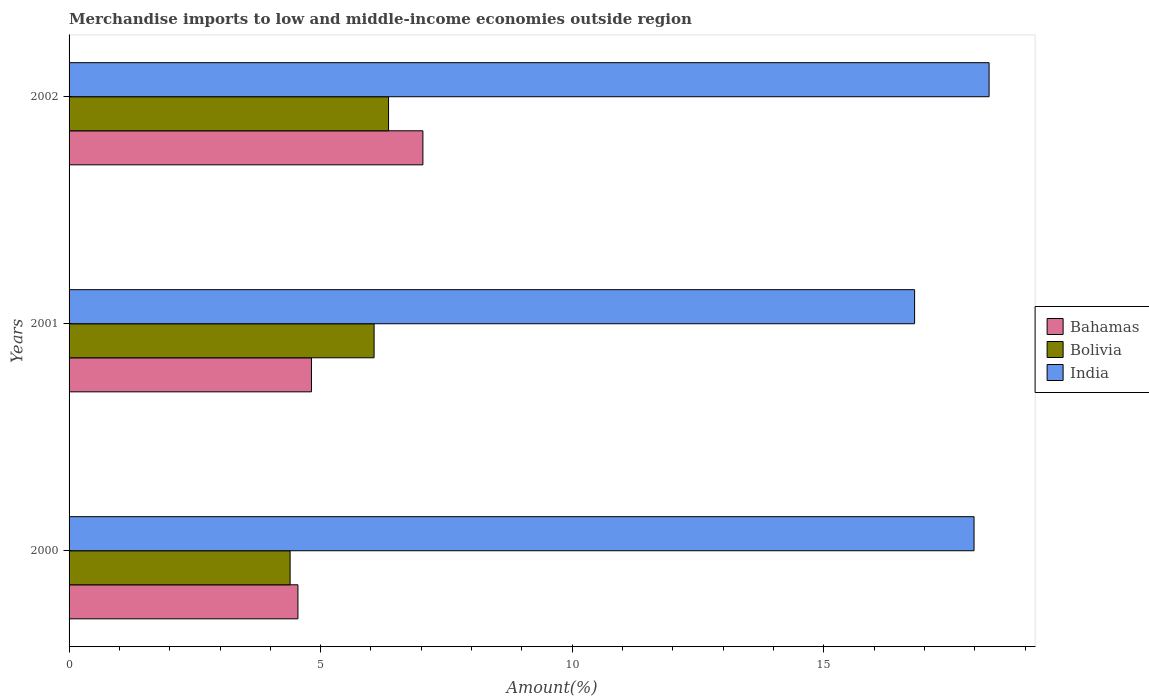How many different coloured bars are there?
Provide a short and direct response. 3. Are the number of bars per tick equal to the number of legend labels?
Offer a very short reply. Yes. What is the label of the 2nd group of bars from the top?
Offer a very short reply. 2001. What is the percentage of amount earned from merchandise imports in Bahamas in 2002?
Keep it short and to the point. 7.03. Across all years, what is the maximum percentage of amount earned from merchandise imports in India?
Your answer should be very brief. 18.28. Across all years, what is the minimum percentage of amount earned from merchandise imports in Bahamas?
Your answer should be very brief. 4.55. In which year was the percentage of amount earned from merchandise imports in Bahamas maximum?
Your answer should be very brief. 2002. What is the total percentage of amount earned from merchandise imports in Bahamas in the graph?
Ensure brevity in your answer.  16.4. What is the difference between the percentage of amount earned from merchandise imports in Bolivia in 2001 and that in 2002?
Your answer should be very brief. -0.29. What is the difference between the percentage of amount earned from merchandise imports in India in 2001 and the percentage of amount earned from merchandise imports in Bolivia in 2002?
Offer a terse response. 10.45. What is the average percentage of amount earned from merchandise imports in Bolivia per year?
Keep it short and to the point. 5.6. In the year 2000, what is the difference between the percentage of amount earned from merchandise imports in Bolivia and percentage of amount earned from merchandise imports in India?
Provide a short and direct response. -13.59. What is the ratio of the percentage of amount earned from merchandise imports in India in 2000 to that in 2001?
Keep it short and to the point. 1.07. What is the difference between the highest and the second highest percentage of amount earned from merchandise imports in Bolivia?
Provide a short and direct response. 0.29. What is the difference between the highest and the lowest percentage of amount earned from merchandise imports in Bolivia?
Your answer should be compact. 1.96. What does the 3rd bar from the top in 2002 represents?
Give a very brief answer. Bahamas. How many bars are there?
Provide a short and direct response. 9. Are all the bars in the graph horizontal?
Provide a short and direct response. Yes. What is the difference between two consecutive major ticks on the X-axis?
Make the answer very short. 5. Are the values on the major ticks of X-axis written in scientific E-notation?
Ensure brevity in your answer.  No. What is the title of the graph?
Provide a succinct answer. Merchandise imports to low and middle-income economies outside region. What is the label or title of the X-axis?
Provide a succinct answer. Amount(%). What is the label or title of the Y-axis?
Keep it short and to the point. Years. What is the Amount(%) of Bahamas in 2000?
Make the answer very short. 4.55. What is the Amount(%) in Bolivia in 2000?
Ensure brevity in your answer.  4.39. What is the Amount(%) of India in 2000?
Your response must be concise. 17.99. What is the Amount(%) of Bahamas in 2001?
Offer a very short reply. 4.82. What is the Amount(%) in Bolivia in 2001?
Your answer should be compact. 6.06. What is the Amount(%) of India in 2001?
Give a very brief answer. 16.8. What is the Amount(%) in Bahamas in 2002?
Give a very brief answer. 7.03. What is the Amount(%) in Bolivia in 2002?
Make the answer very short. 6.35. What is the Amount(%) of India in 2002?
Provide a short and direct response. 18.28. Across all years, what is the maximum Amount(%) of Bahamas?
Your answer should be very brief. 7.03. Across all years, what is the maximum Amount(%) of Bolivia?
Offer a very short reply. 6.35. Across all years, what is the maximum Amount(%) in India?
Make the answer very short. 18.28. Across all years, what is the minimum Amount(%) in Bahamas?
Your response must be concise. 4.55. Across all years, what is the minimum Amount(%) of Bolivia?
Make the answer very short. 4.39. Across all years, what is the minimum Amount(%) of India?
Provide a succinct answer. 16.8. What is the total Amount(%) of Bahamas in the graph?
Provide a short and direct response. 16.4. What is the total Amount(%) of Bolivia in the graph?
Your response must be concise. 16.8. What is the total Amount(%) of India in the graph?
Your response must be concise. 53.07. What is the difference between the Amount(%) of Bahamas in 2000 and that in 2001?
Provide a succinct answer. -0.27. What is the difference between the Amount(%) of Bolivia in 2000 and that in 2001?
Give a very brief answer. -1.67. What is the difference between the Amount(%) in India in 2000 and that in 2001?
Your response must be concise. 1.18. What is the difference between the Amount(%) in Bahamas in 2000 and that in 2002?
Ensure brevity in your answer.  -2.48. What is the difference between the Amount(%) of Bolivia in 2000 and that in 2002?
Give a very brief answer. -1.96. What is the difference between the Amount(%) of India in 2000 and that in 2002?
Provide a succinct answer. -0.3. What is the difference between the Amount(%) in Bahamas in 2001 and that in 2002?
Your answer should be compact. -2.22. What is the difference between the Amount(%) in Bolivia in 2001 and that in 2002?
Your answer should be very brief. -0.29. What is the difference between the Amount(%) in India in 2001 and that in 2002?
Your response must be concise. -1.48. What is the difference between the Amount(%) of Bahamas in 2000 and the Amount(%) of Bolivia in 2001?
Offer a very short reply. -1.51. What is the difference between the Amount(%) in Bahamas in 2000 and the Amount(%) in India in 2001?
Your answer should be compact. -12.26. What is the difference between the Amount(%) in Bolivia in 2000 and the Amount(%) in India in 2001?
Provide a succinct answer. -12.41. What is the difference between the Amount(%) in Bahamas in 2000 and the Amount(%) in Bolivia in 2002?
Your response must be concise. -1.8. What is the difference between the Amount(%) in Bahamas in 2000 and the Amount(%) in India in 2002?
Ensure brevity in your answer.  -13.74. What is the difference between the Amount(%) of Bolivia in 2000 and the Amount(%) of India in 2002?
Your answer should be compact. -13.89. What is the difference between the Amount(%) in Bahamas in 2001 and the Amount(%) in Bolivia in 2002?
Your answer should be compact. -1.53. What is the difference between the Amount(%) of Bahamas in 2001 and the Amount(%) of India in 2002?
Make the answer very short. -13.47. What is the difference between the Amount(%) in Bolivia in 2001 and the Amount(%) in India in 2002?
Offer a terse response. -12.22. What is the average Amount(%) of Bahamas per year?
Provide a short and direct response. 5.47. What is the average Amount(%) of Bolivia per year?
Make the answer very short. 5.6. What is the average Amount(%) of India per year?
Ensure brevity in your answer.  17.69. In the year 2000, what is the difference between the Amount(%) of Bahamas and Amount(%) of Bolivia?
Offer a very short reply. 0.16. In the year 2000, what is the difference between the Amount(%) in Bahamas and Amount(%) in India?
Provide a short and direct response. -13.44. In the year 2000, what is the difference between the Amount(%) in Bolivia and Amount(%) in India?
Your response must be concise. -13.59. In the year 2001, what is the difference between the Amount(%) of Bahamas and Amount(%) of Bolivia?
Offer a terse response. -1.25. In the year 2001, what is the difference between the Amount(%) in Bahamas and Amount(%) in India?
Offer a very short reply. -11.99. In the year 2001, what is the difference between the Amount(%) in Bolivia and Amount(%) in India?
Your answer should be very brief. -10.74. In the year 2002, what is the difference between the Amount(%) of Bahamas and Amount(%) of Bolivia?
Provide a short and direct response. 0.68. In the year 2002, what is the difference between the Amount(%) in Bahamas and Amount(%) in India?
Provide a short and direct response. -11.25. In the year 2002, what is the difference between the Amount(%) of Bolivia and Amount(%) of India?
Provide a succinct answer. -11.94. What is the ratio of the Amount(%) of Bahamas in 2000 to that in 2001?
Provide a short and direct response. 0.94. What is the ratio of the Amount(%) in Bolivia in 2000 to that in 2001?
Offer a terse response. 0.72. What is the ratio of the Amount(%) in India in 2000 to that in 2001?
Give a very brief answer. 1.07. What is the ratio of the Amount(%) of Bahamas in 2000 to that in 2002?
Give a very brief answer. 0.65. What is the ratio of the Amount(%) in Bolivia in 2000 to that in 2002?
Keep it short and to the point. 0.69. What is the ratio of the Amount(%) of India in 2000 to that in 2002?
Your response must be concise. 0.98. What is the ratio of the Amount(%) of Bahamas in 2001 to that in 2002?
Your answer should be compact. 0.69. What is the ratio of the Amount(%) of Bolivia in 2001 to that in 2002?
Your response must be concise. 0.95. What is the ratio of the Amount(%) of India in 2001 to that in 2002?
Your answer should be very brief. 0.92. What is the difference between the highest and the second highest Amount(%) in Bahamas?
Keep it short and to the point. 2.22. What is the difference between the highest and the second highest Amount(%) of Bolivia?
Your response must be concise. 0.29. What is the difference between the highest and the second highest Amount(%) of India?
Offer a very short reply. 0.3. What is the difference between the highest and the lowest Amount(%) of Bahamas?
Offer a terse response. 2.48. What is the difference between the highest and the lowest Amount(%) in Bolivia?
Your answer should be very brief. 1.96. What is the difference between the highest and the lowest Amount(%) of India?
Your answer should be very brief. 1.48. 